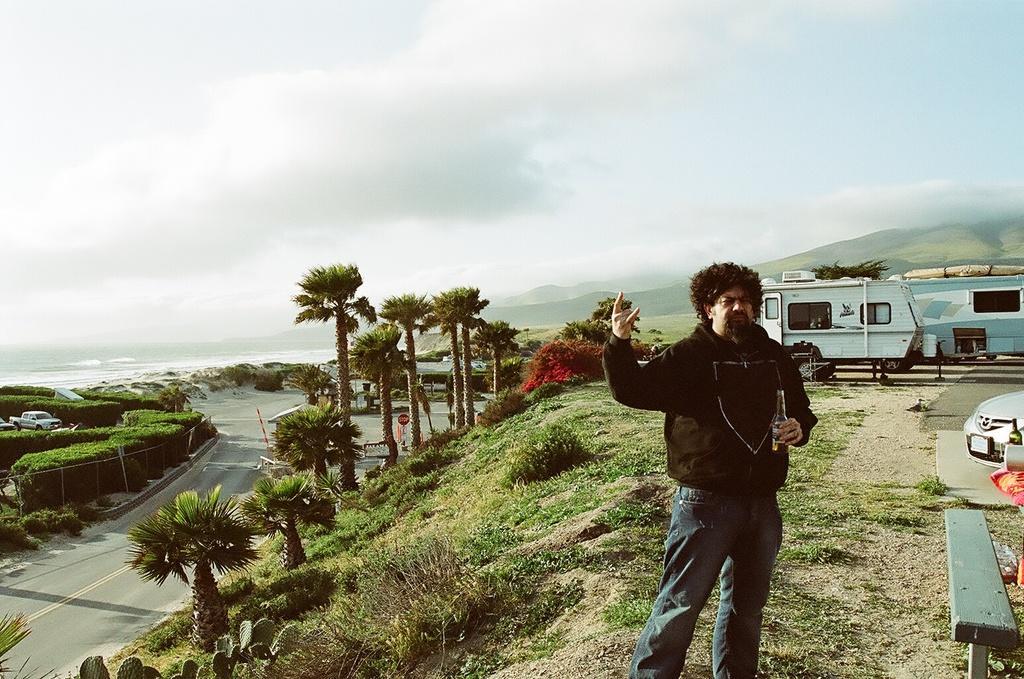Can you describe this image briefly? In this image on the right side we can see a man is standing and holding a bottle in his hand and there are vehicles, objects and grass on the ground. In the background there are trees, vehicles on the road, plants, sign board poles, water, house, mountains and clouds in the sky. 